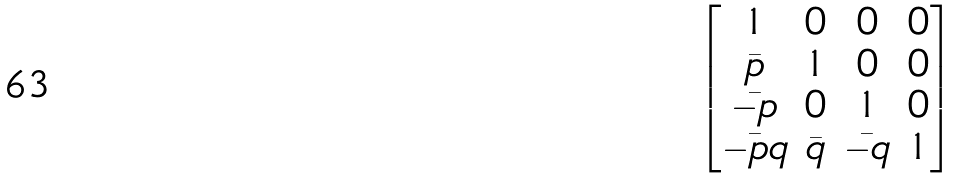<formula> <loc_0><loc_0><loc_500><loc_500>\begin{bmatrix} 1 & 0 & 0 & 0 \\ \bar { p } & 1 & 0 & 0 \\ \bar { - p } & 0 & 1 & 0 \\ \bar { - p q } & \bar { q } & \bar { - q } & 1 \end{bmatrix}</formula> 